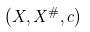<formula> <loc_0><loc_0><loc_500><loc_500>\left ( X , X ^ { \# } , c \right )</formula> 